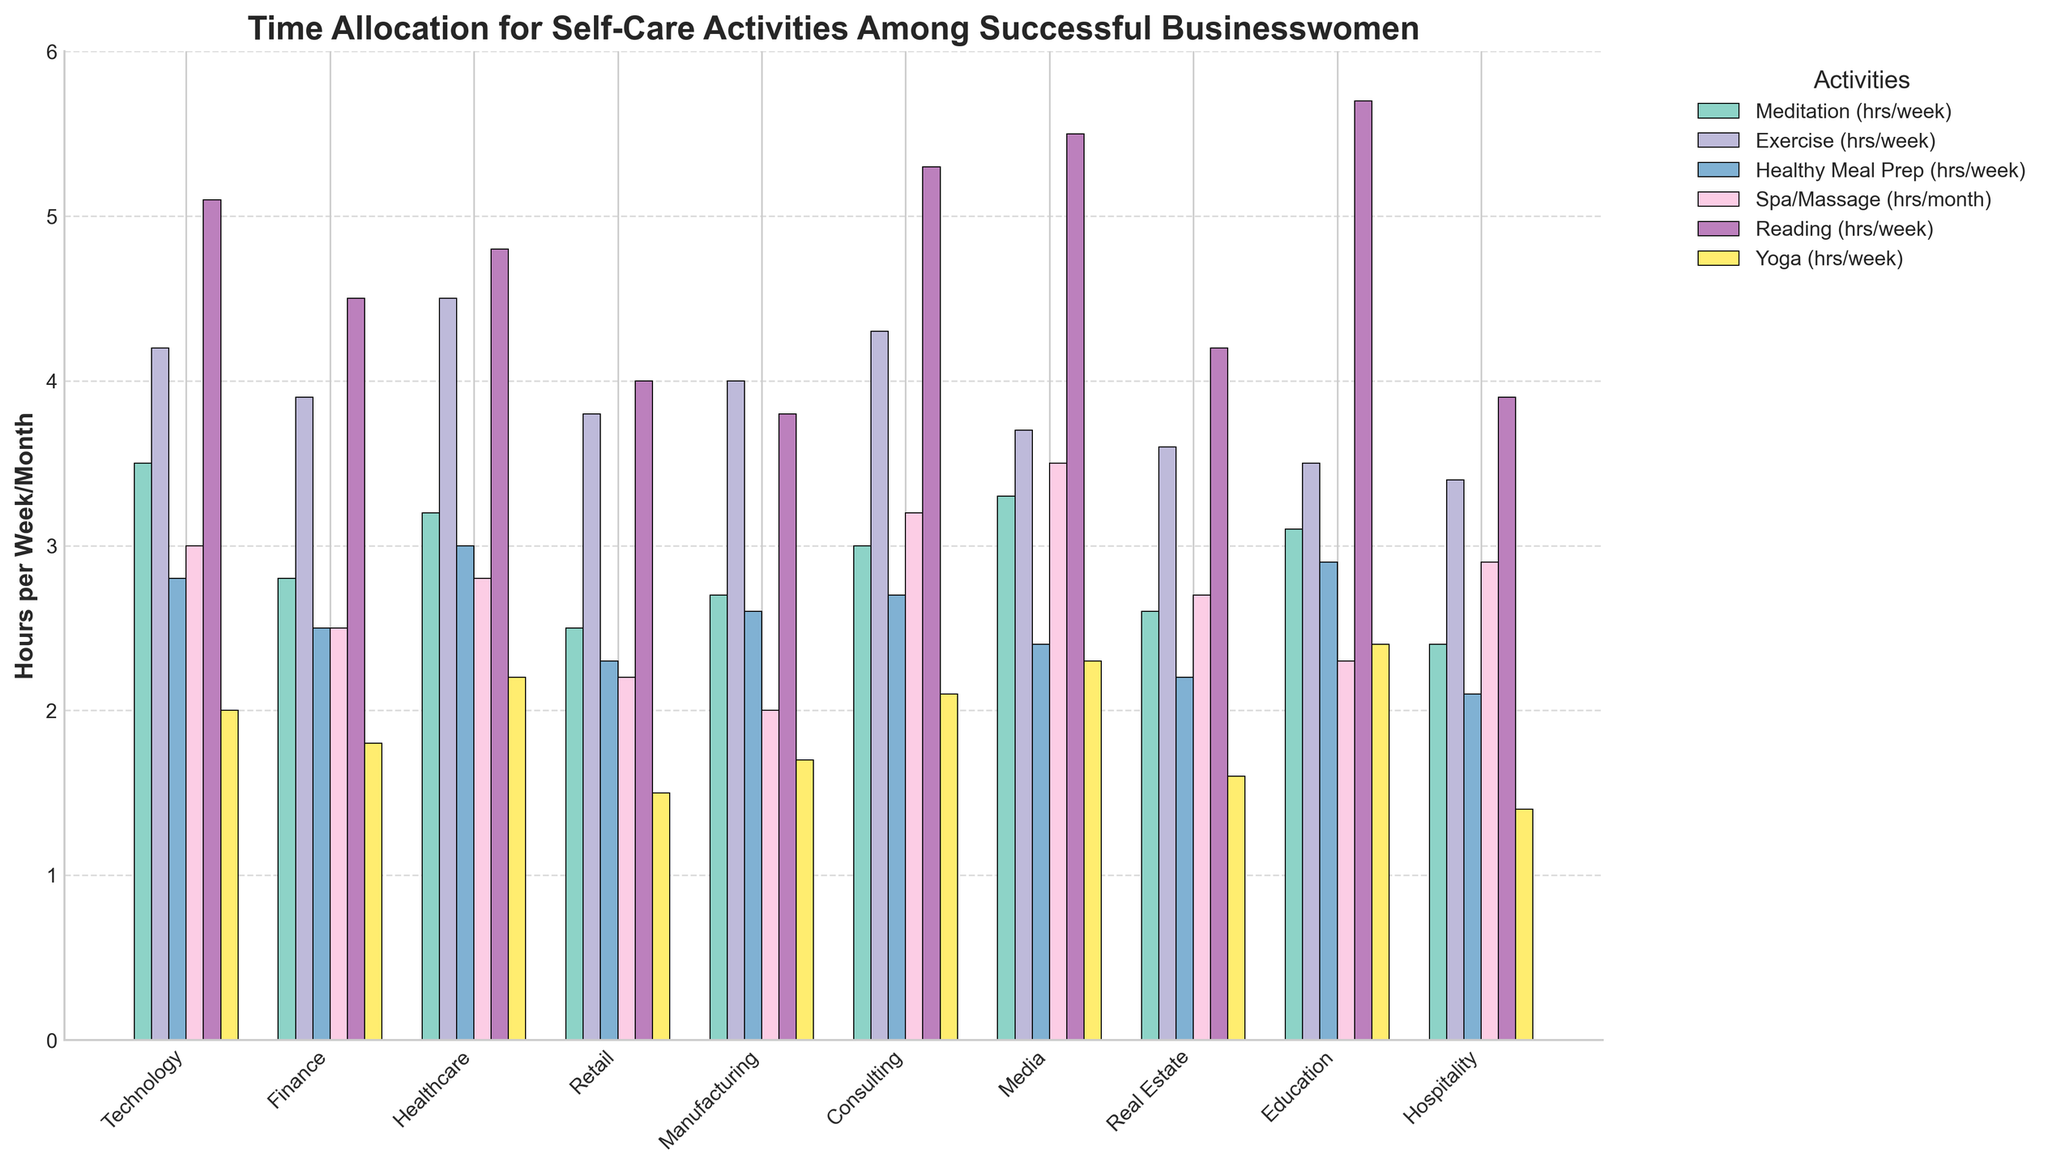what industry allocates the most time to exercise? By looking at the bar chart, find the industry with the tallest bar in the "Exercise" category. The tallest bar represents the maximum time allocated.
Answer: Healthcare What is the total weekly time spent on Meditation and Yoga by women in Consulting? Find the height of the bars corresponding to Meditation and Yoga for Consulting, then sum them up: Meditation (3.0 hours) + Yoga (2.1 hours).
Answer: 5.1 hours Which industries spend an equal amount of time on "Spa/Massage"? Find the bars of "Spa/Massage" that have the same height. Both Technology and Consulting have bars at the same height (3.0 hours each).
Answer: Technology, Consulting How much more time do businesswomen in Media spend reading compared to those in Manufacturing? Find the difference between the height of the "Reading" bars for Media (5.5 hours) and Manufacturing (3.8 hours). Calculate the difference: 5.5 - 3.8.
Answer: 1.7 hours In which activity does Healthcare spend the least amount of time? Examine the bars for Healthcare and identify the shortest one, which represents the least amount of time spent on an activity. The shortest bar for Healthcare is "Yoga" (2.2 hours).
Answer: Yoga What is the average time spent weekly on Exercise across all industries? Sum the heights of all the bars for Exercise and divide by the number of industries: (4.2 + 3.9 + 4.5 + 3.8 + 4.0 + 4.3 + 3.7 + 3.6 + 3.5 + 3.4) / 10 = 3.89 hours.
Answer: 3.89 hours Which industry values reading the most, and how much time do they allocate weekly for it? Find the tallest bar in the "Reading" category to identify the industry that spends the most time, which is Education with 5.7 hours.
Answer: Education, 5.7 hours Between Technology and Real Estate, which industry spends less time on Healthy Meal Prep, and what is the time difference? Compare the bars for "Healthy Meal Prep" for both industries: Technology (2.8 hours) and Real Estate (2.2 hours). Technology spends more, so Real Estate spends less. The difference is 2.8 - 2.2.
Answer: Real Estate, 0.6 hours 